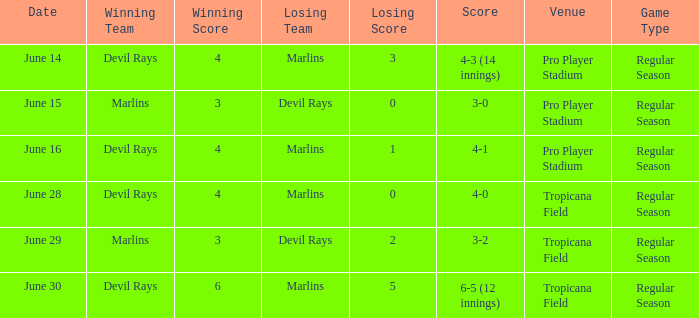What was the result on june 29 when the devil rays lost? 3-2. 